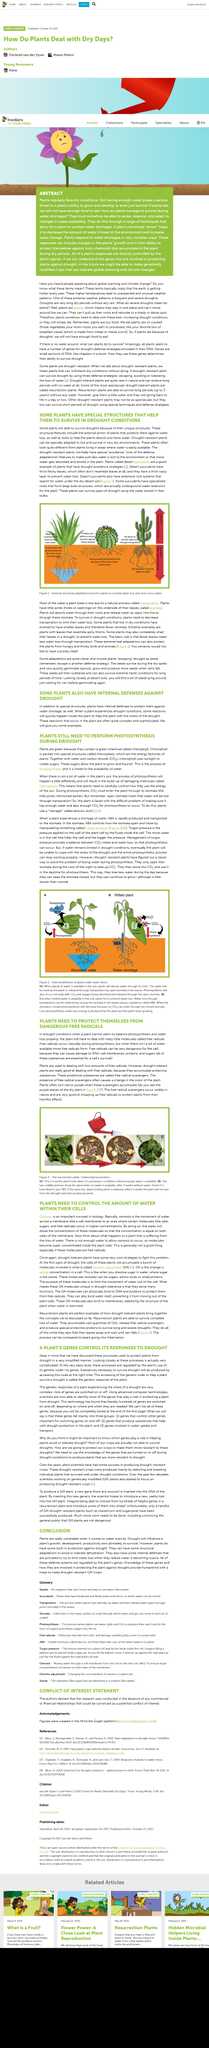Specify some key components in this picture. The internal defenses of plants under water stress are being investigated in this image. This article explores the relationship between plants and free radicals. The title of the article is "PLANTS NEED TO PROTECT THEMSELVES FROM DANGEROUS FREE RADICALS" which discusses the importance of plants protecting themselves from harmful substances in order to maintain their health and survival. Plants are typically green due to their possession of chlorophyll, a green chemical pigment. Turgor pressure is the pressure applied on the wall of a plant cell by the fluids inside the cell. This pressure helps maintain the shape and structure of the plant cell. 